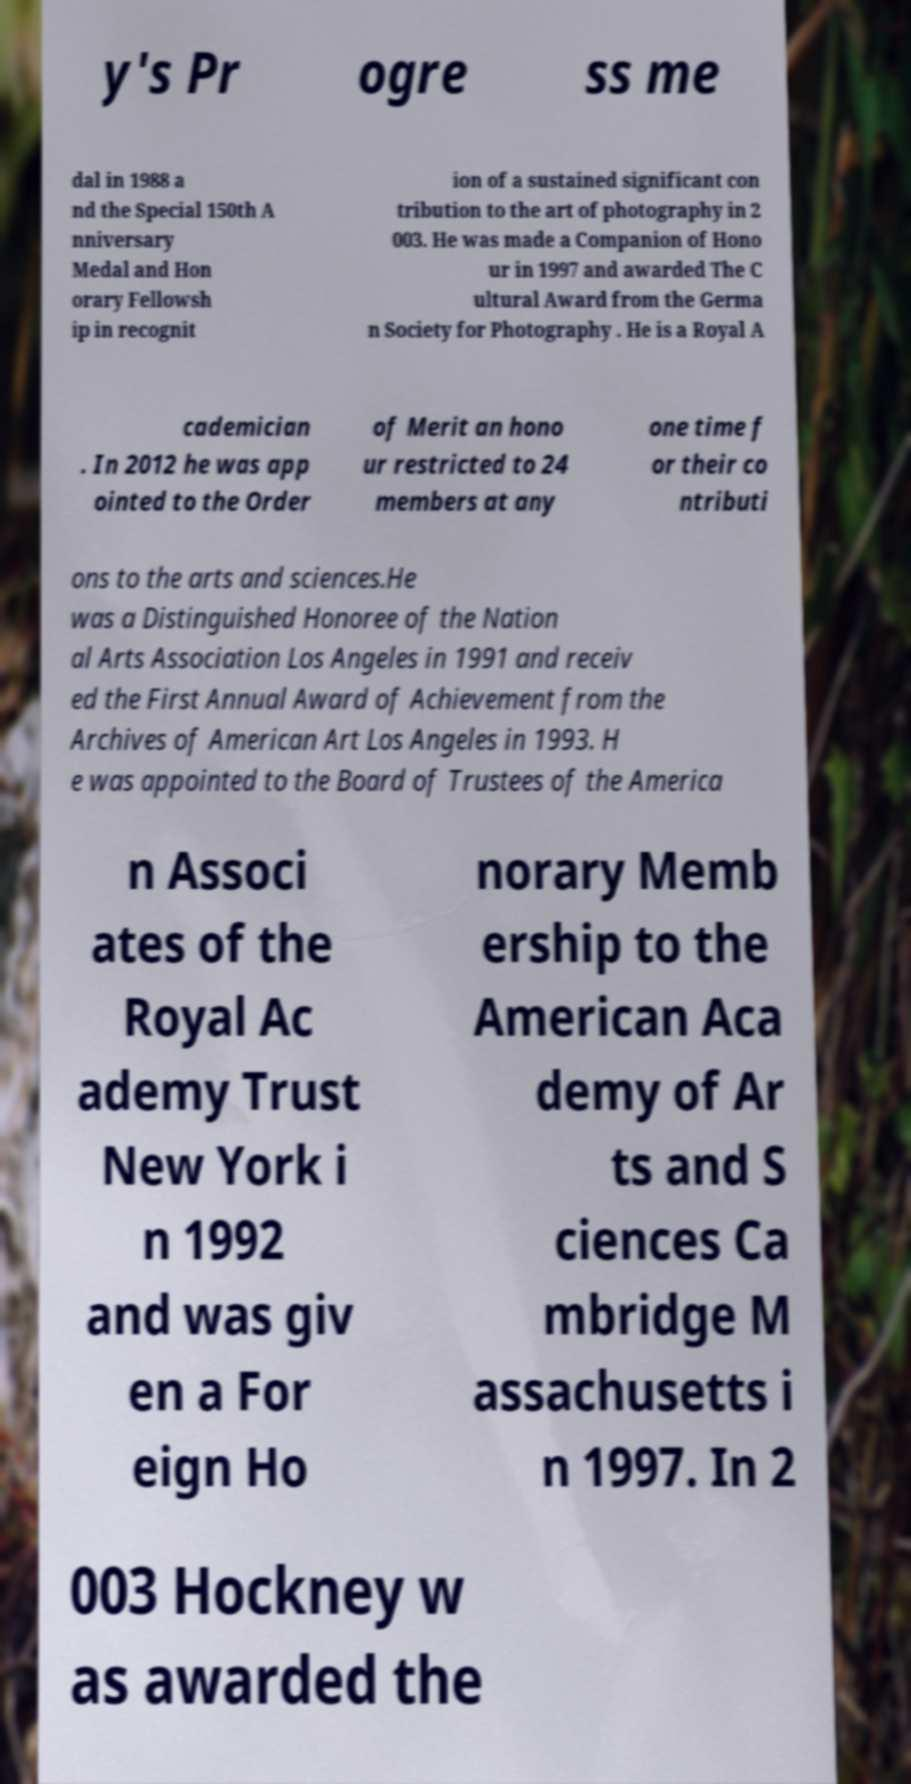There's text embedded in this image that I need extracted. Can you transcribe it verbatim? y's Pr ogre ss me dal in 1988 a nd the Special 150th A nniversary Medal and Hon orary Fellowsh ip in recognit ion of a sustained significant con tribution to the art of photography in 2 003. He was made a Companion of Hono ur in 1997 and awarded The C ultural Award from the Germa n Society for Photography . He is a Royal A cademician . In 2012 he was app ointed to the Order of Merit an hono ur restricted to 24 members at any one time f or their co ntributi ons to the arts and sciences.He was a Distinguished Honoree of the Nation al Arts Association Los Angeles in 1991 and receiv ed the First Annual Award of Achievement from the Archives of American Art Los Angeles in 1993. H e was appointed to the Board of Trustees of the America n Associ ates of the Royal Ac ademy Trust New York i n 1992 and was giv en a For eign Ho norary Memb ership to the American Aca demy of Ar ts and S ciences Ca mbridge M assachusetts i n 1997. In 2 003 Hockney w as awarded the 